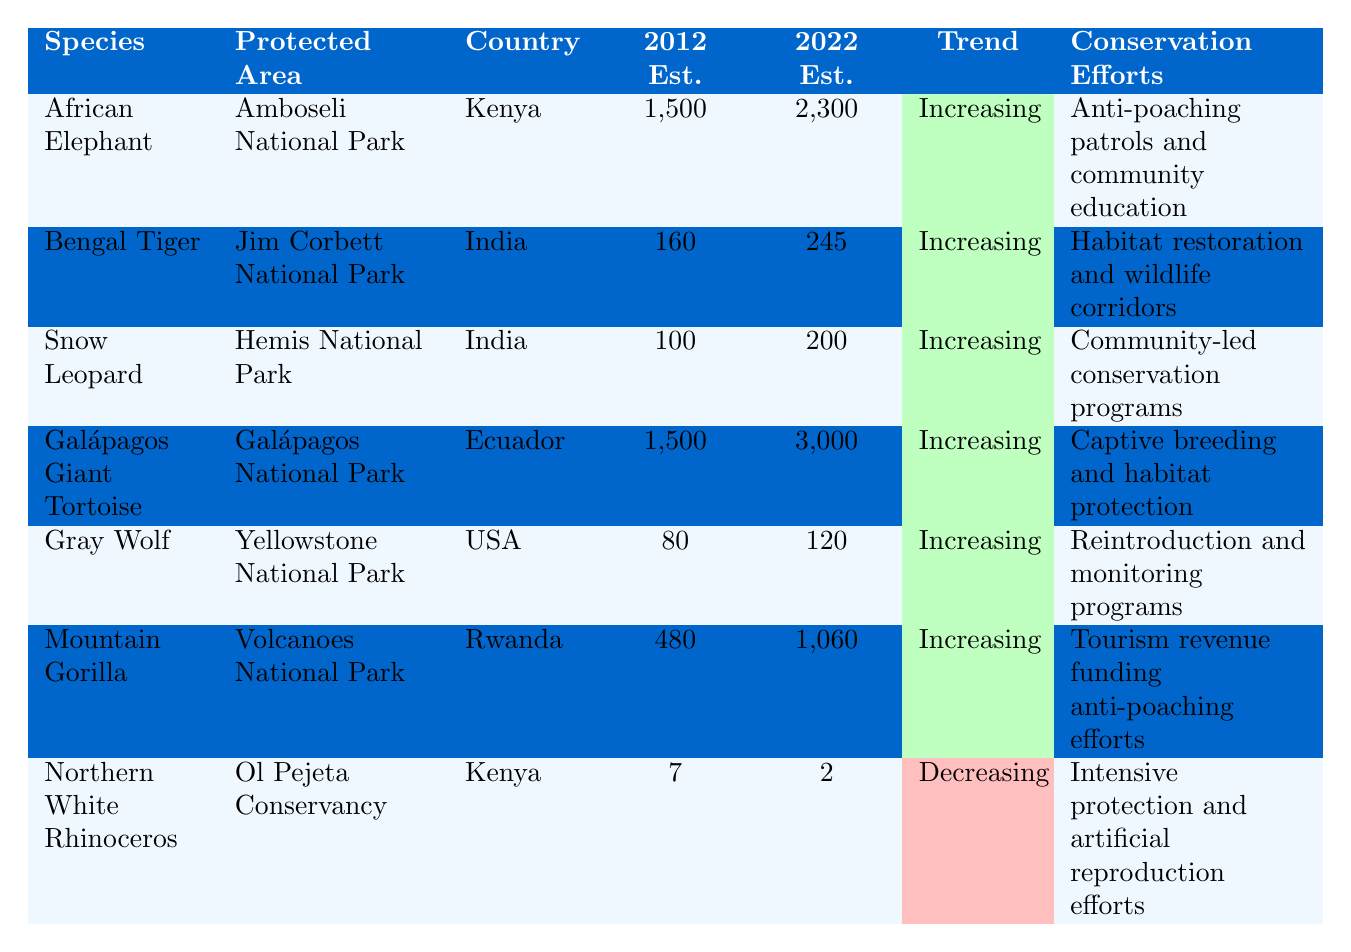What is the population estimate of the African Elephant in 2022? The table provides the population estimate for the African Elephant under the "2022 Est." column, showing a value of 2300.
Answer: 2300 Which species has the highest population estimate in 2022? Comparing the values listed under the "2022 Est." column, the Galápagos Giant Tortoise has the highest population estimate at 3000.
Answer: Galápagos Giant Tortoise What is the difference in the population estimates for the Northern White Rhinoceros from 2012 to 2022? The population estimate for the Northern White Rhinoceros in 2012 is 7, and in 2022 it is 2. The difference is calculated as 7 - 2 = 5.
Answer: 5 Are all the species listed in the table experiencing increasing population trends? Reviewing the "Trend" column, all species except the Northern White Rhinoceros show an increasing trend, indicating that not all species are experiencing increases.
Answer: No What is the average population estimate for the species listed in 2022? To find the average, sum all the 2022 estimates, which are 2300 + 245 + 200 + 3000 + 120 + 1060 + 2 = 5727. Then divide by the number of species (7), resulting in 5727 / 7 ≈ 817.43.
Answer: 817.43 Which country's protected area has the most significant increase in wildlife population from 2012 to 2022? The increase in population is calculated by subtracting the population estimate from 2012 from that of 2022 for each species: African Elephant: 2300 - 1500 = 800; Bengal Tiger: 245 - 160 = 85; Snow Leopard: 200 - 100 = 100; Galápagos Giant Tortoise: 3000 - 1500 = 1500; Gray Wolf: 120 - 80 = 40; Mountain Gorilla: 1060 - 480 = 580; Northern White Rhinoceros: 2 - 7 = -5. The Galápagos Giant Tortoise has the highest increase of 1500, which is in Ecuador.
Answer: Ecuador What conservation effort is associated with the Mountain Gorilla? The table indicates that the conservation effort for the Mountain Gorilla is related to tourism revenue funding anti-poaching efforts.
Answer: Tourism revenue funding anti-poaching efforts Is the population of the Gray Wolf increasing or decreasing? Referring to the "Trend" column for the Gray Wolf, it is categorized as "Increasing," indicating a positive trend in its population.
Answer: Increasing 